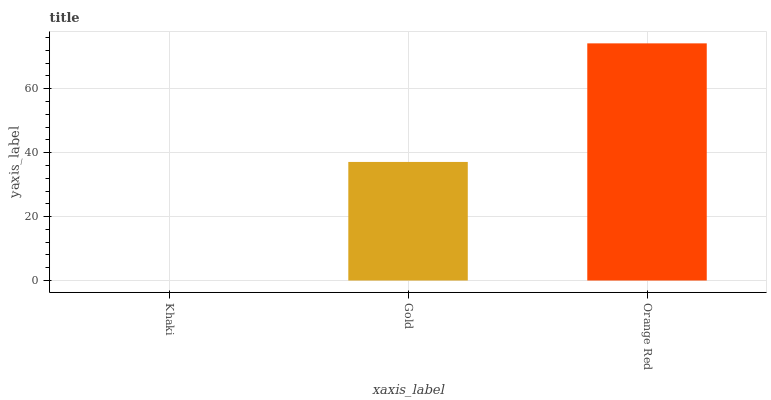Is Gold the minimum?
Answer yes or no. No. Is Gold the maximum?
Answer yes or no. No. Is Gold greater than Khaki?
Answer yes or no. Yes. Is Khaki less than Gold?
Answer yes or no. Yes. Is Khaki greater than Gold?
Answer yes or no. No. Is Gold less than Khaki?
Answer yes or no. No. Is Gold the high median?
Answer yes or no. Yes. Is Gold the low median?
Answer yes or no. Yes. Is Khaki the high median?
Answer yes or no. No. Is Orange Red the low median?
Answer yes or no. No. 